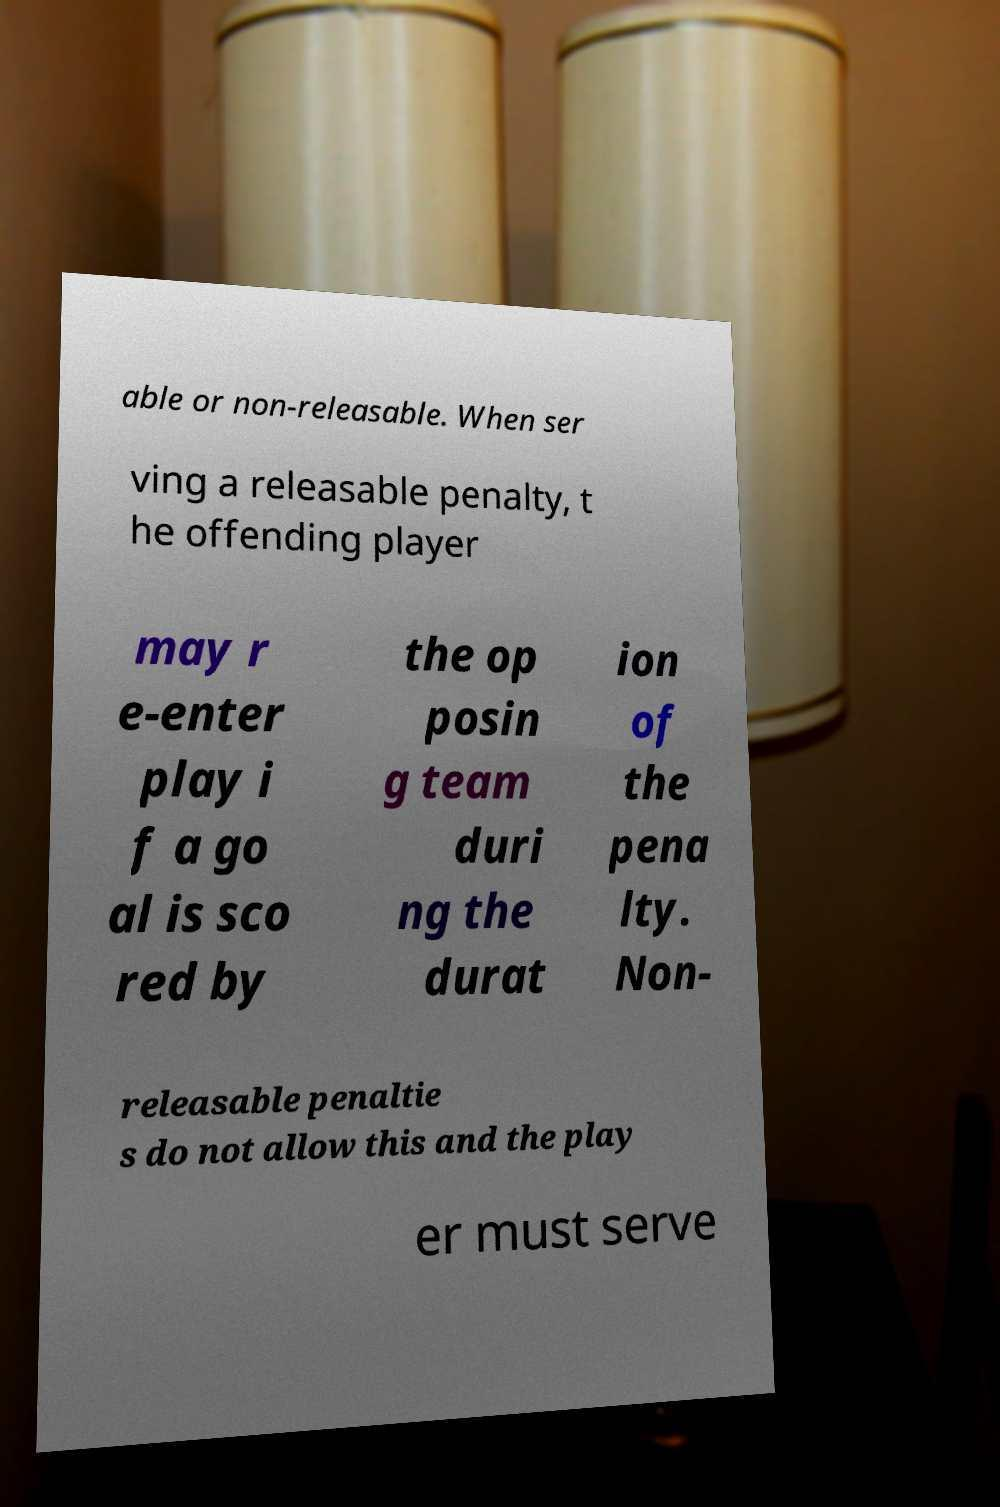What messages or text are displayed in this image? I need them in a readable, typed format. able or non-releasable. When ser ving a releasable penalty, t he offending player may r e-enter play i f a go al is sco red by the op posin g team duri ng the durat ion of the pena lty. Non- releasable penaltie s do not allow this and the play er must serve 